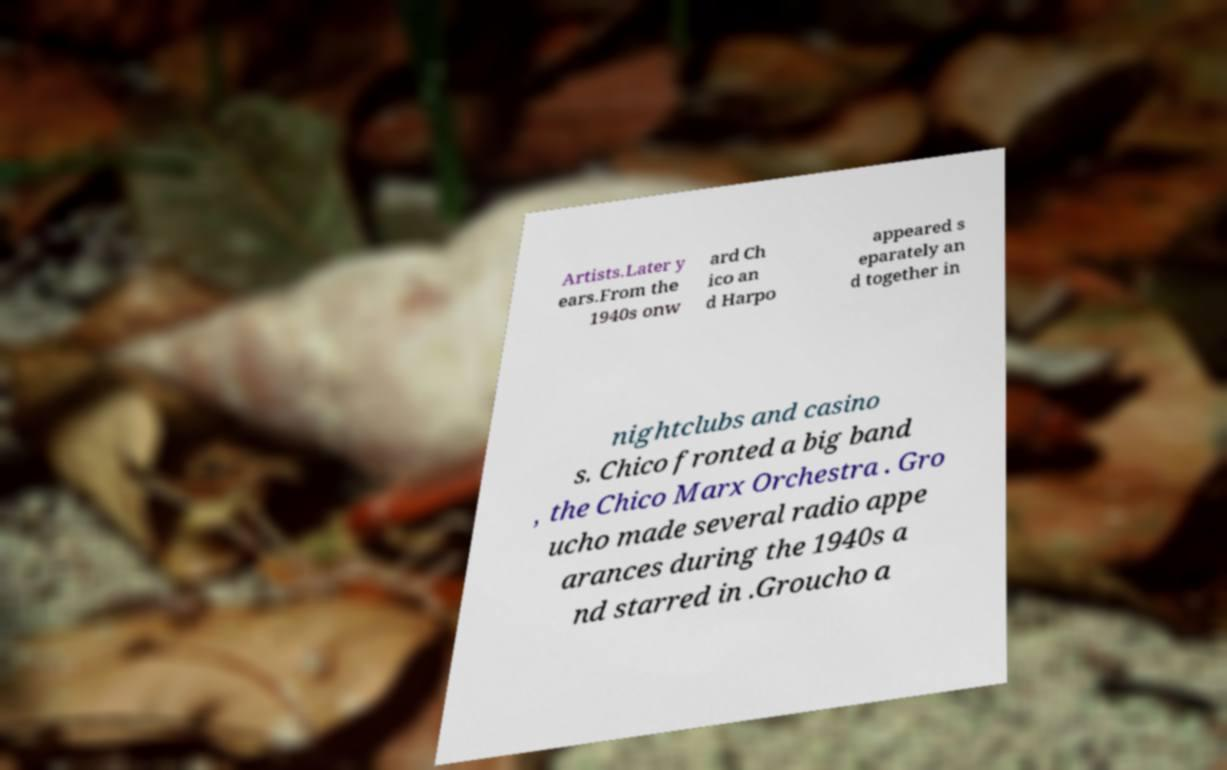Please read and relay the text visible in this image. What does it say? Artists.Later y ears.From the 1940s onw ard Ch ico an d Harpo appeared s eparately an d together in nightclubs and casino s. Chico fronted a big band , the Chico Marx Orchestra . Gro ucho made several radio appe arances during the 1940s a nd starred in .Groucho a 